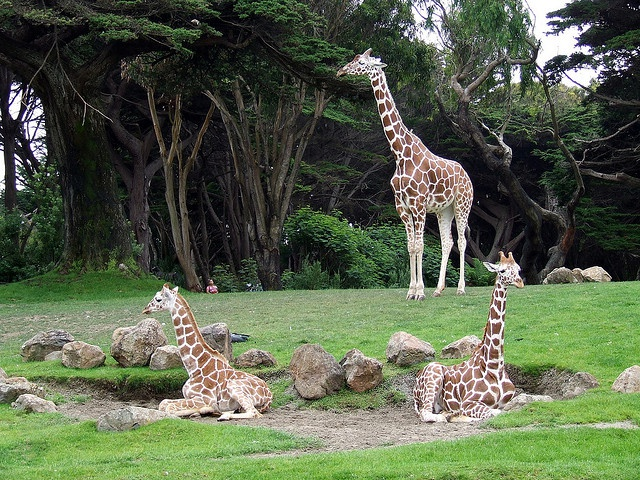Describe the objects in this image and their specific colors. I can see giraffe in darkgreen, white, darkgray, and gray tones, giraffe in darkgreen, white, gray, and darkgray tones, giraffe in darkgreen, white, gray, darkgray, and tan tones, and people in darkgreen, black, gray, and lightpink tones in this image. 